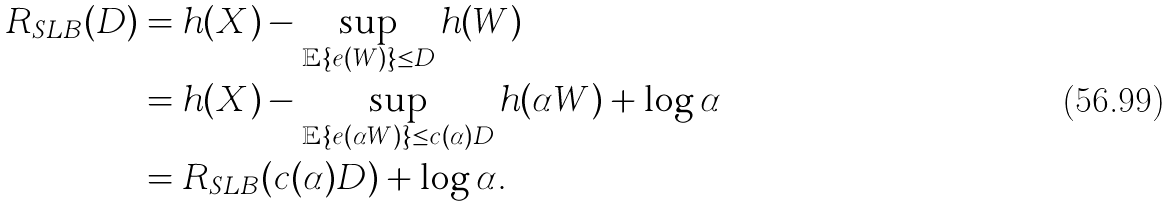Convert formula to latex. <formula><loc_0><loc_0><loc_500><loc_500>R _ { S L B } ( D ) & = h ( X ) - \sup _ { \mathbb { E } \{ e ( W ) \} \leq D } h ( W ) \\ & = h ( X ) - \sup _ { \mathbb { E } \{ e ( \alpha W ) \} \leq c ( \alpha ) D } h ( \alpha W ) + \log \alpha \\ & = R _ { S L B } ( c ( \alpha ) D ) + \log \alpha .</formula> 